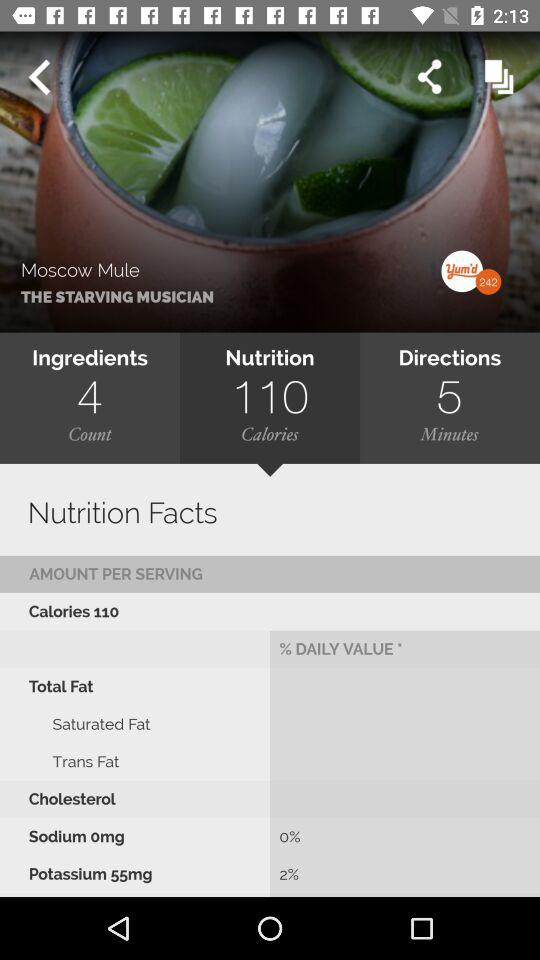What is the daily value of "Potassium 55mg" in percentage? The daily value of "Potassium 55mg" in percentage is 2. 